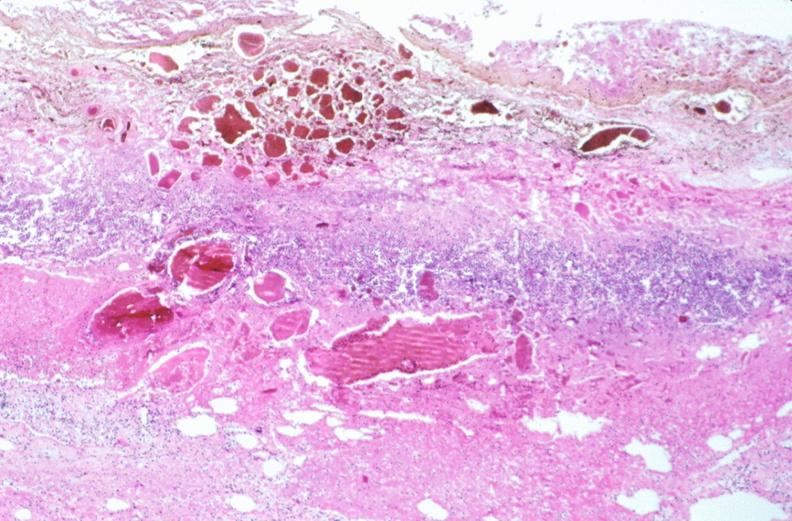what does this image show?
Answer the question using a single word or phrase. Stomach 